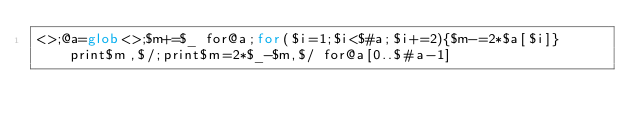Convert code to text. <code><loc_0><loc_0><loc_500><loc_500><_Perl_><>;@a=glob<>;$m+=$_ for@a;for($i=1;$i<$#a;$i+=2){$m-=2*$a[$i]}print$m,$/;print$m=2*$_-$m,$/ for@a[0..$#a-1]</code> 